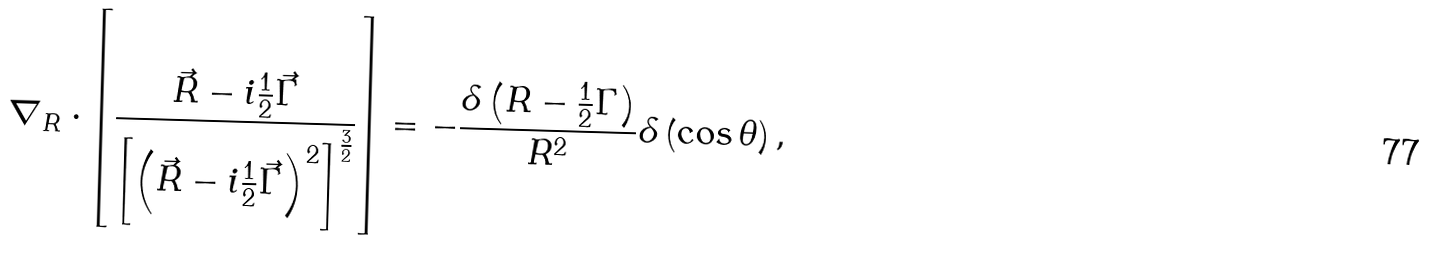Convert formula to latex. <formula><loc_0><loc_0><loc_500><loc_500>\nabla _ { R } \cdot \left [ \frac { \vec { R } - i \frac { 1 } { 2 } \vec { \Gamma } } { \left [ \left ( \vec { R } - i \frac { 1 } { 2 } \vec { \Gamma } \right ) ^ { 2 } \right ] ^ { \frac { 3 } { 2 } } } \right ] = - \frac { \delta \left ( R - \frac { 1 } { 2 } \Gamma \right ) } { R ^ { 2 } } \delta \left ( \cos \theta \right ) ,</formula> 